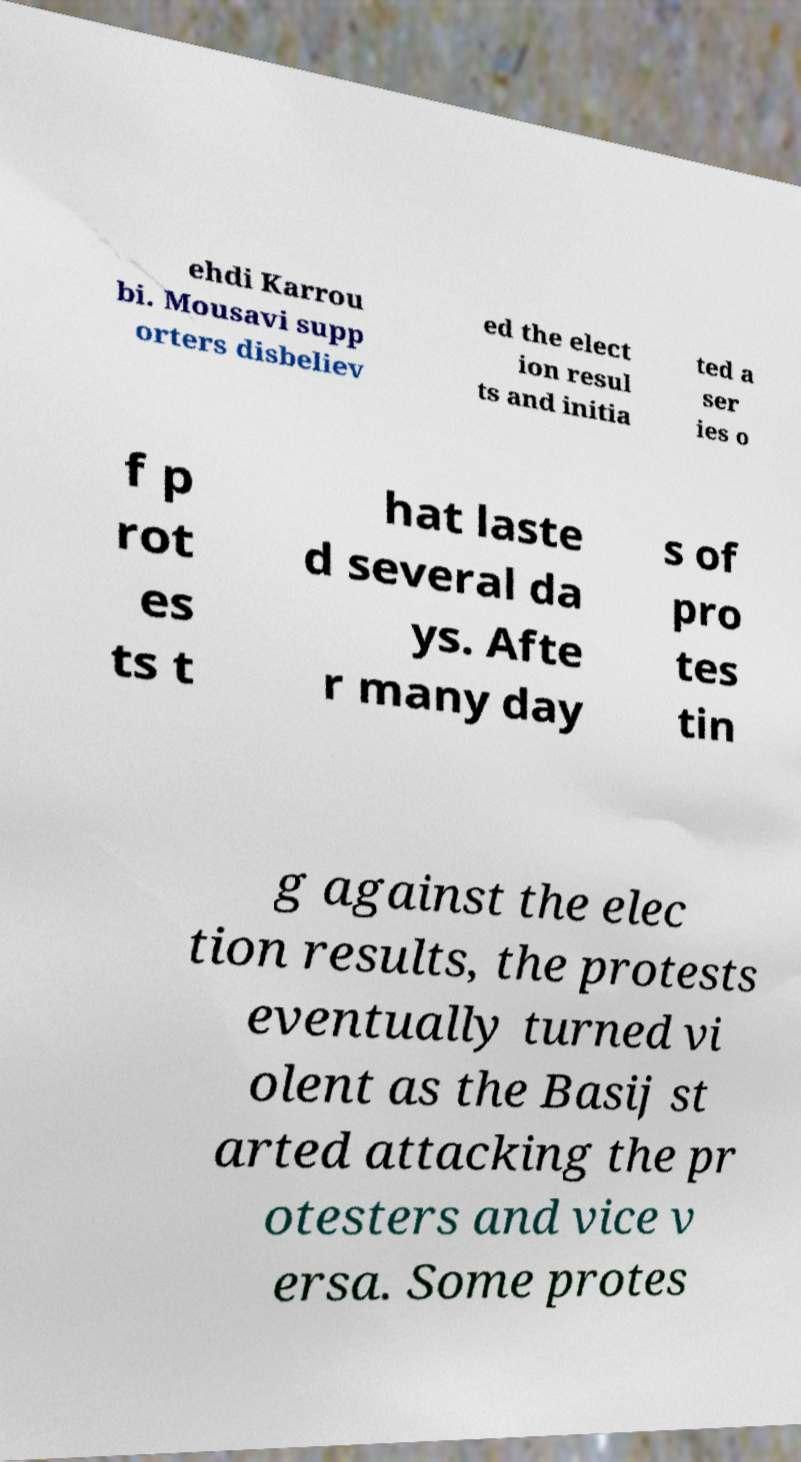Please read and relay the text visible in this image. What does it say? ehdi Karrou bi. Mousavi supp orters disbeliev ed the elect ion resul ts and initia ted a ser ies o f p rot es ts t hat laste d several da ys. Afte r many day s of pro tes tin g against the elec tion results, the protests eventually turned vi olent as the Basij st arted attacking the pr otesters and vice v ersa. Some protes 